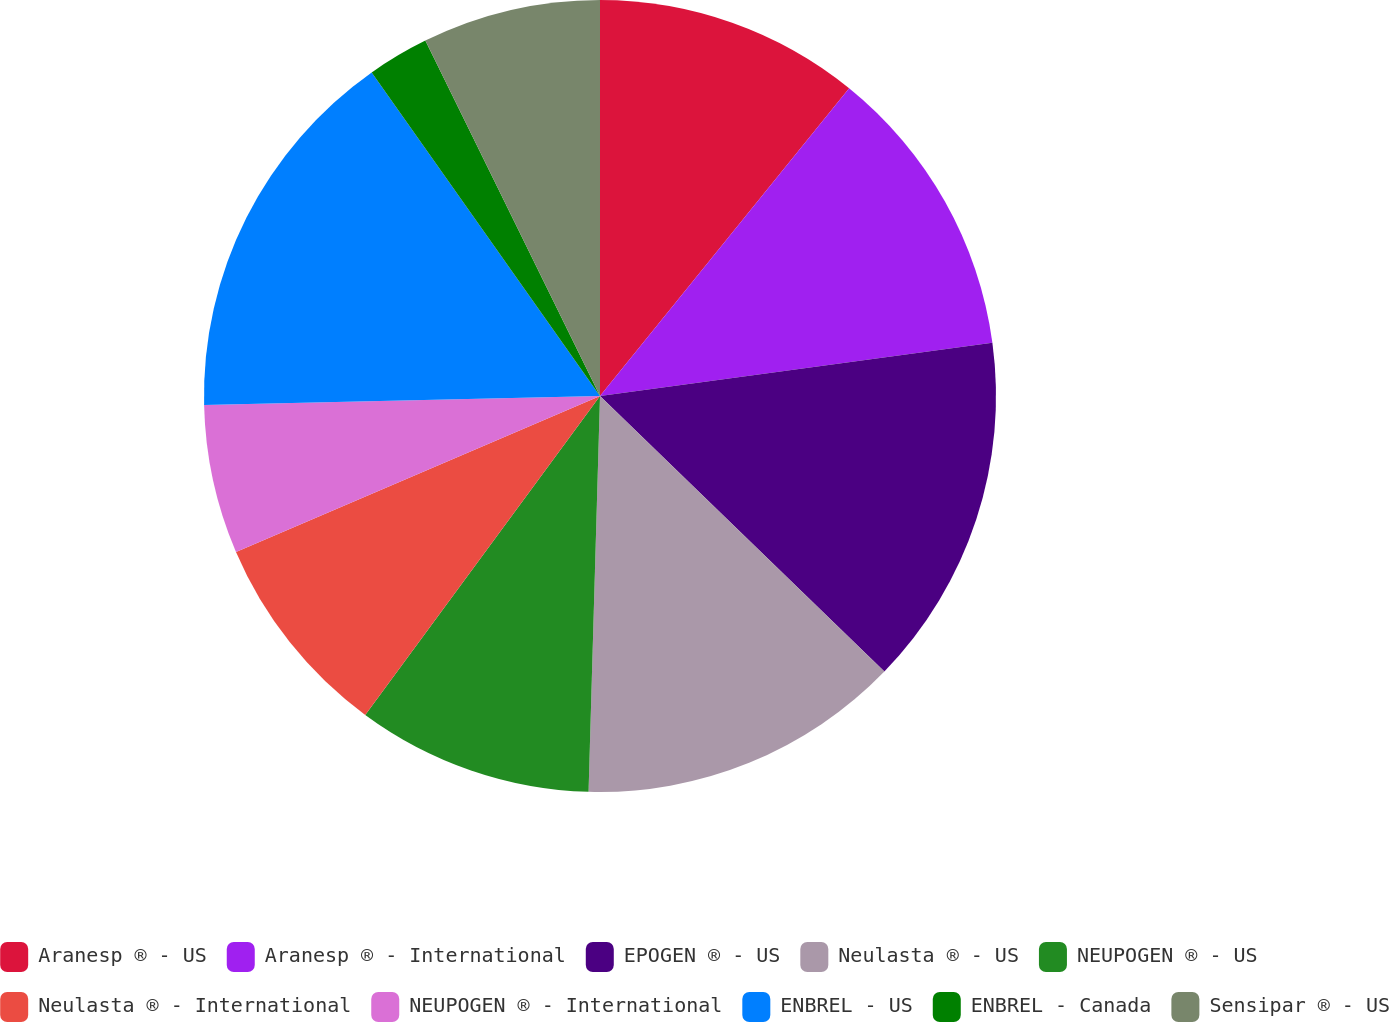Convert chart to OTSL. <chart><loc_0><loc_0><loc_500><loc_500><pie_chart><fcel>Aranesp ® - US<fcel>Aranesp ® - International<fcel>EPOGEN ® - US<fcel>Neulasta ® - US<fcel>NEUPOGEN ® - US<fcel>Neulasta ® - International<fcel>NEUPOGEN ® - International<fcel>ENBREL - US<fcel>ENBREL - Canada<fcel>Sensipar ® - US<nl><fcel>10.83%<fcel>12.02%<fcel>14.4%<fcel>13.21%<fcel>9.64%<fcel>8.46%<fcel>6.08%<fcel>15.58%<fcel>2.51%<fcel>7.27%<nl></chart> 